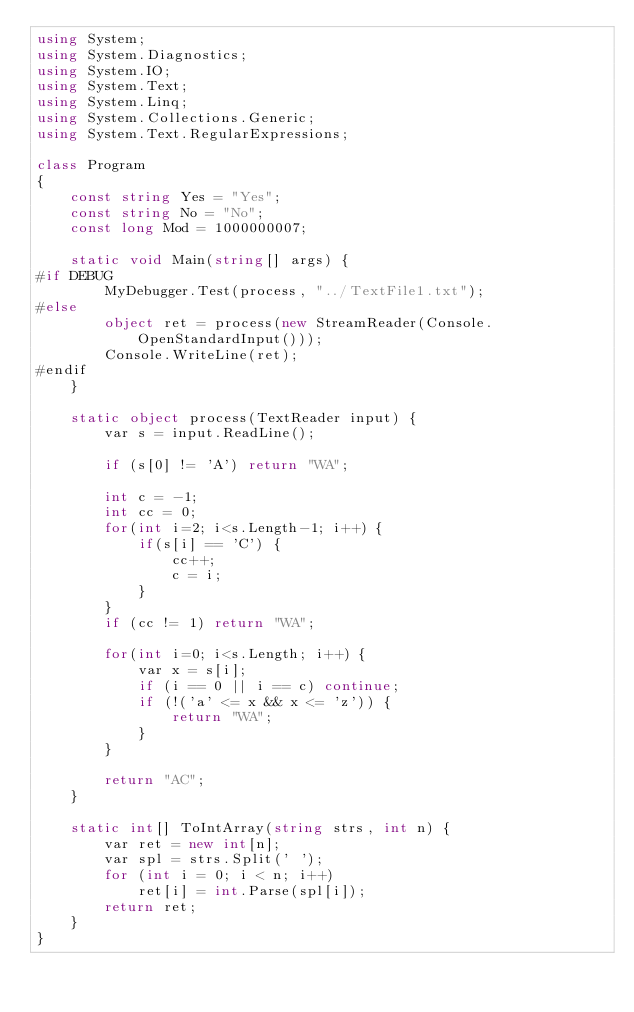<code> <loc_0><loc_0><loc_500><loc_500><_C#_>using System;
using System.Diagnostics;
using System.IO;
using System.Text;
using System.Linq;
using System.Collections.Generic;
using System.Text.RegularExpressions;

class Program
{
    const string Yes = "Yes";
    const string No = "No";
    const long Mod = 1000000007;

    static void Main(string[] args) {
#if DEBUG
        MyDebugger.Test(process, "../TextFile1.txt");
#else
        object ret = process(new StreamReader(Console.OpenStandardInput()));
        Console.WriteLine(ret);
#endif
    }

    static object process(TextReader input) {
        var s = input.ReadLine();

        if (s[0] != 'A') return "WA";

        int c = -1;
        int cc = 0;
        for(int i=2; i<s.Length-1; i++) {
            if(s[i] == 'C') {
                cc++;
                c = i;
            }
        }
        if (cc != 1) return "WA";

        for(int i=0; i<s.Length; i++) {
            var x = s[i];
            if (i == 0 || i == c) continue;
            if (!('a' <= x && x <= 'z')) {
                return "WA";
            }
        }

        return "AC";
    }

    static int[] ToIntArray(string strs, int n) {
        var ret = new int[n];
        var spl = strs.Split(' ');
        for (int i = 0; i < n; i++)
            ret[i] = int.Parse(spl[i]);
        return ret;
    }
}
</code> 